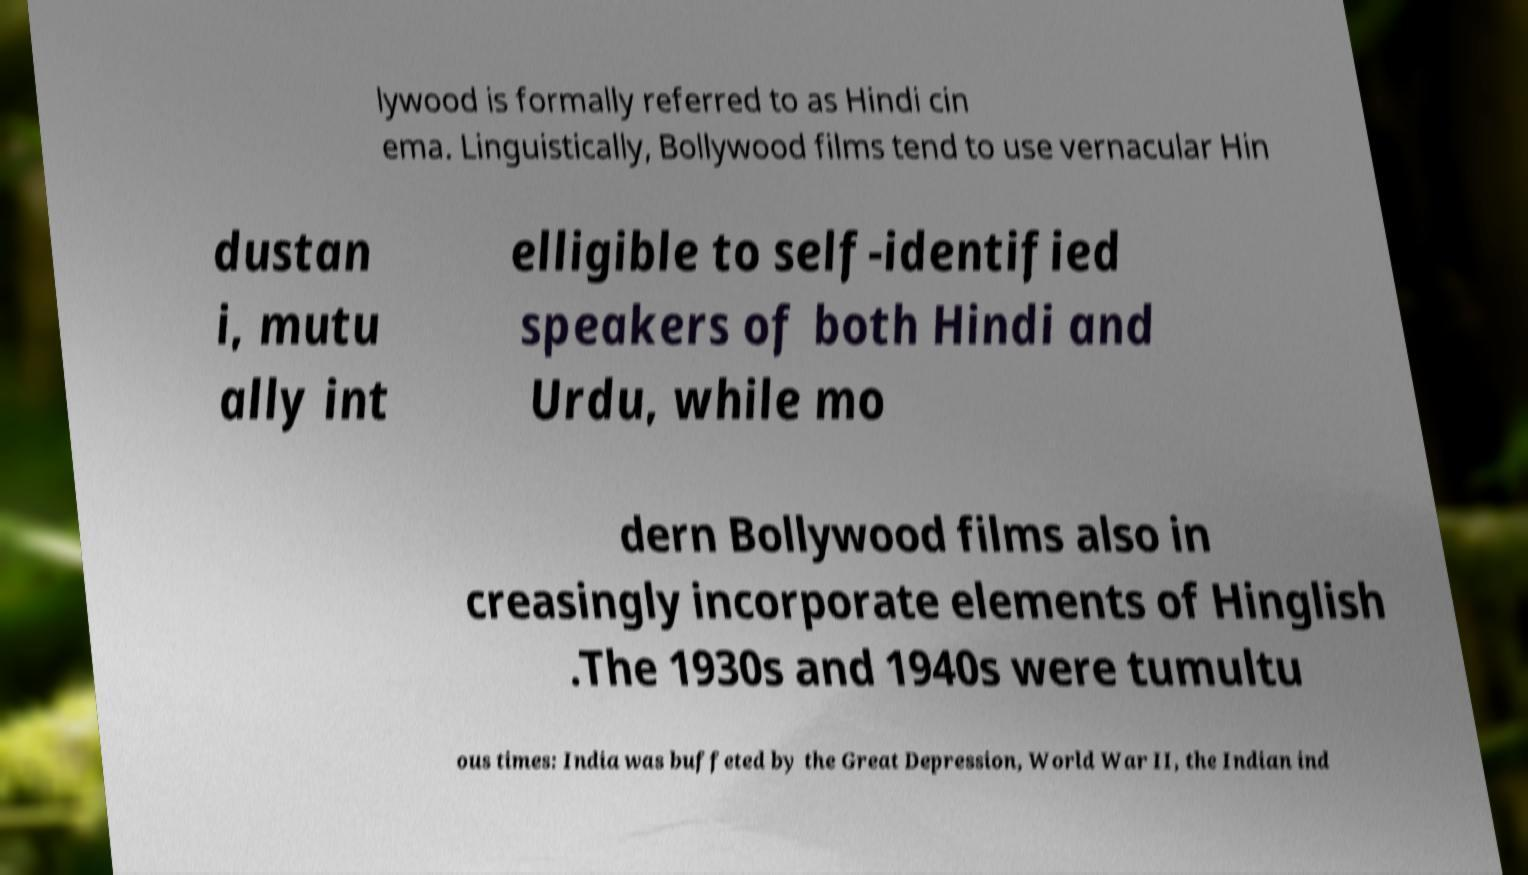What messages or text are displayed in this image? I need them in a readable, typed format. lywood is formally referred to as Hindi cin ema. Linguistically, Bollywood films tend to use vernacular Hin dustan i, mutu ally int elligible to self-identified speakers of both Hindi and Urdu, while mo dern Bollywood films also in creasingly incorporate elements of Hinglish .The 1930s and 1940s were tumultu ous times: India was buffeted by the Great Depression, World War II, the Indian ind 